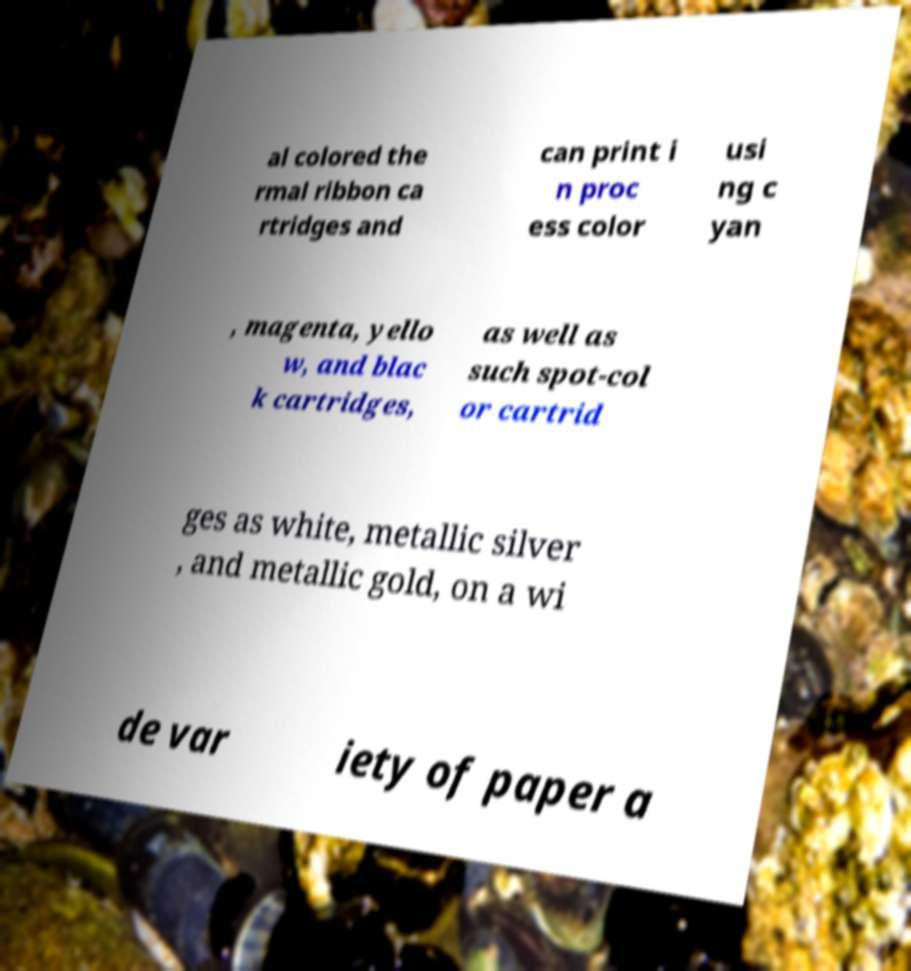There's text embedded in this image that I need extracted. Can you transcribe it verbatim? al colored the rmal ribbon ca rtridges and can print i n proc ess color usi ng c yan , magenta, yello w, and blac k cartridges, as well as such spot-col or cartrid ges as white, metallic silver , and metallic gold, on a wi de var iety of paper a 